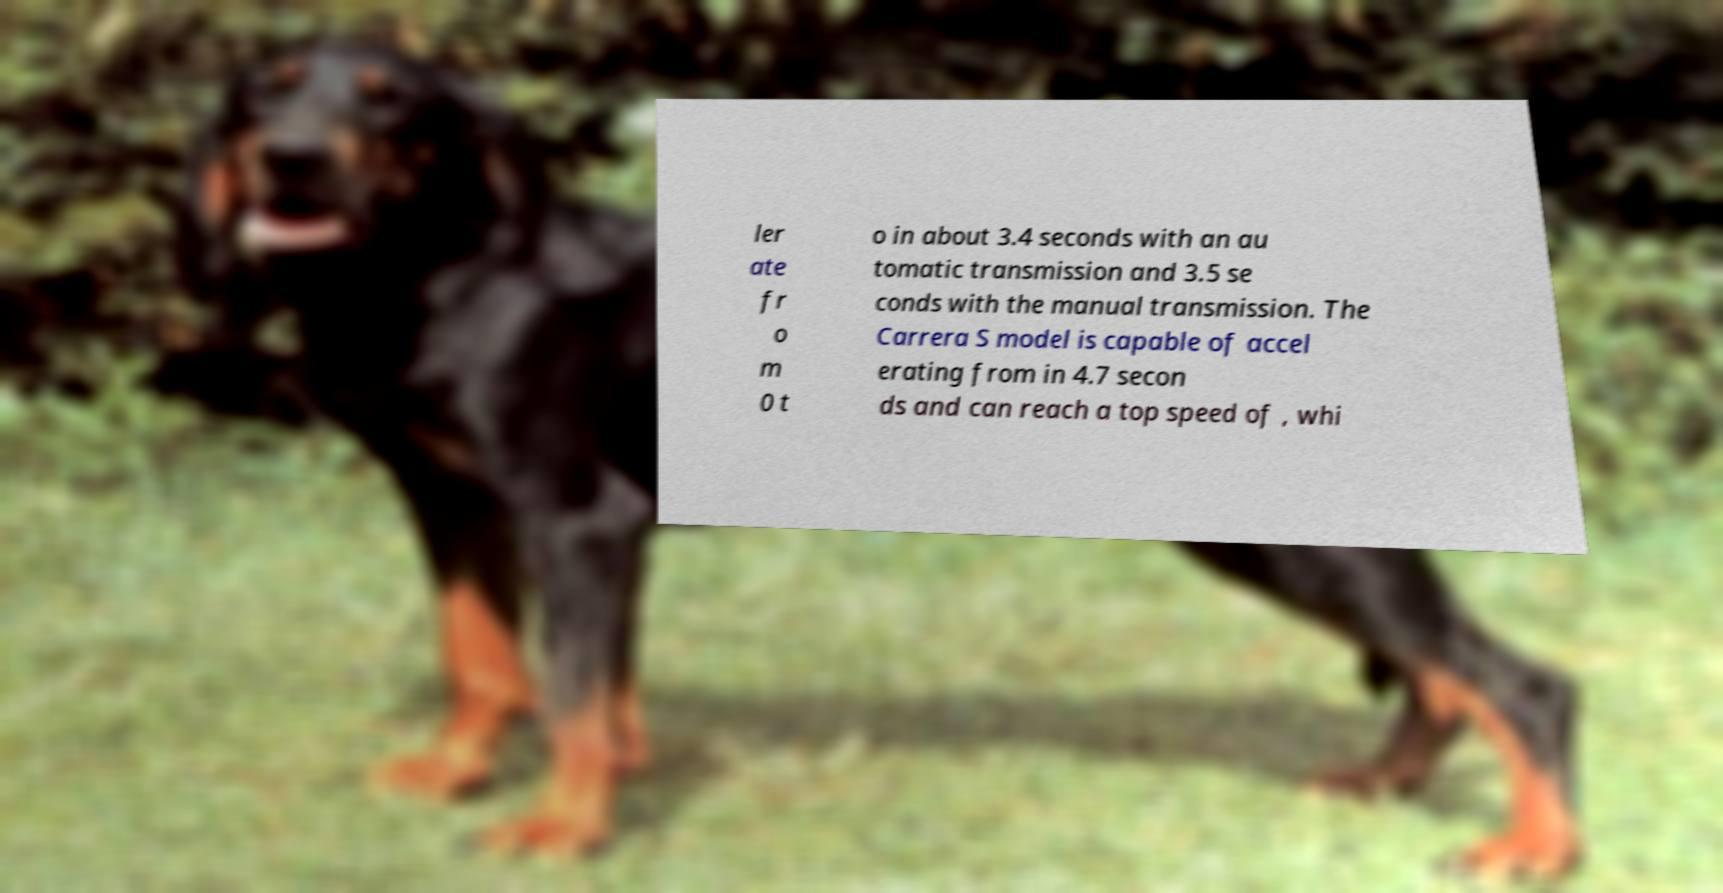For documentation purposes, I need the text within this image transcribed. Could you provide that? ler ate fr o m 0 t o in about 3.4 seconds with an au tomatic transmission and 3.5 se conds with the manual transmission. The Carrera S model is capable of accel erating from in 4.7 secon ds and can reach a top speed of , whi 